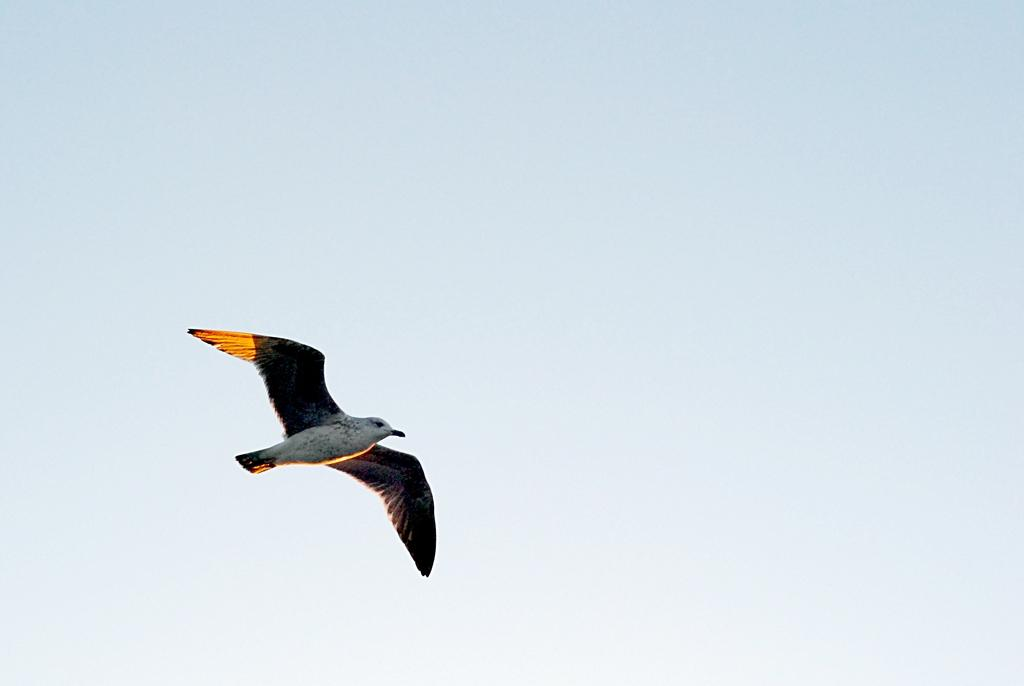What type of animal can be seen in the image? There is a bird in the image. What is the bird doing in the image? The bird is flying in the air. What can be seen in the background of the image? The sky is visible in the background of the image. What type of kettle is visible in the image? There is no kettle present in the image; it features a bird flying in the sky. 